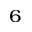Convert formula to latex. <formula><loc_0><loc_0><loc_500><loc_500>^ { 6 }</formula> 